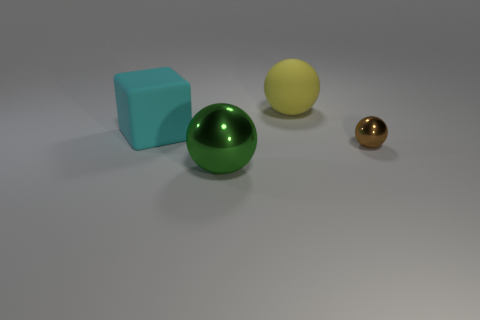Add 1 big yellow metal spheres. How many objects exist? 5 Subtract all spheres. How many objects are left? 1 Add 2 big yellow spheres. How many big yellow spheres are left? 3 Add 1 big gray objects. How many big gray objects exist? 1 Subtract 0 yellow cubes. How many objects are left? 4 Subtract all gray metal balls. Subtract all large cyan things. How many objects are left? 3 